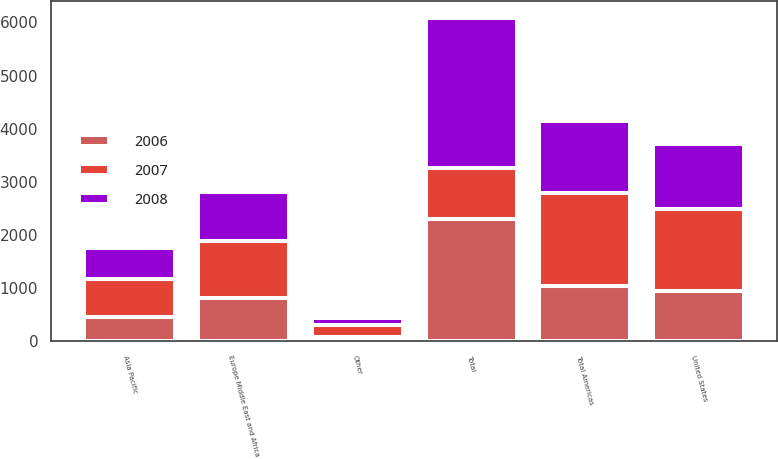Convert chart to OTSL. <chart><loc_0><loc_0><loc_500><loc_500><stacked_bar_chart><ecel><fcel>United States<fcel>Other<fcel>Total Americas<fcel>Europe Middle East and Africa<fcel>Asia Pacific<fcel>Total<nl><fcel>2007<fcel>1537.5<fcel>228.7<fcel>1766.2<fcel>1077.7<fcel>728.5<fcel>950.3<nl><fcel>2008<fcel>1215.8<fcel>124.7<fcel>1340.5<fcel>918<fcel>577.6<fcel>2836.1<nl><fcel>2006<fcel>950.3<fcel>83<fcel>1033.3<fcel>817.4<fcel>452.9<fcel>2303.6<nl></chart> 